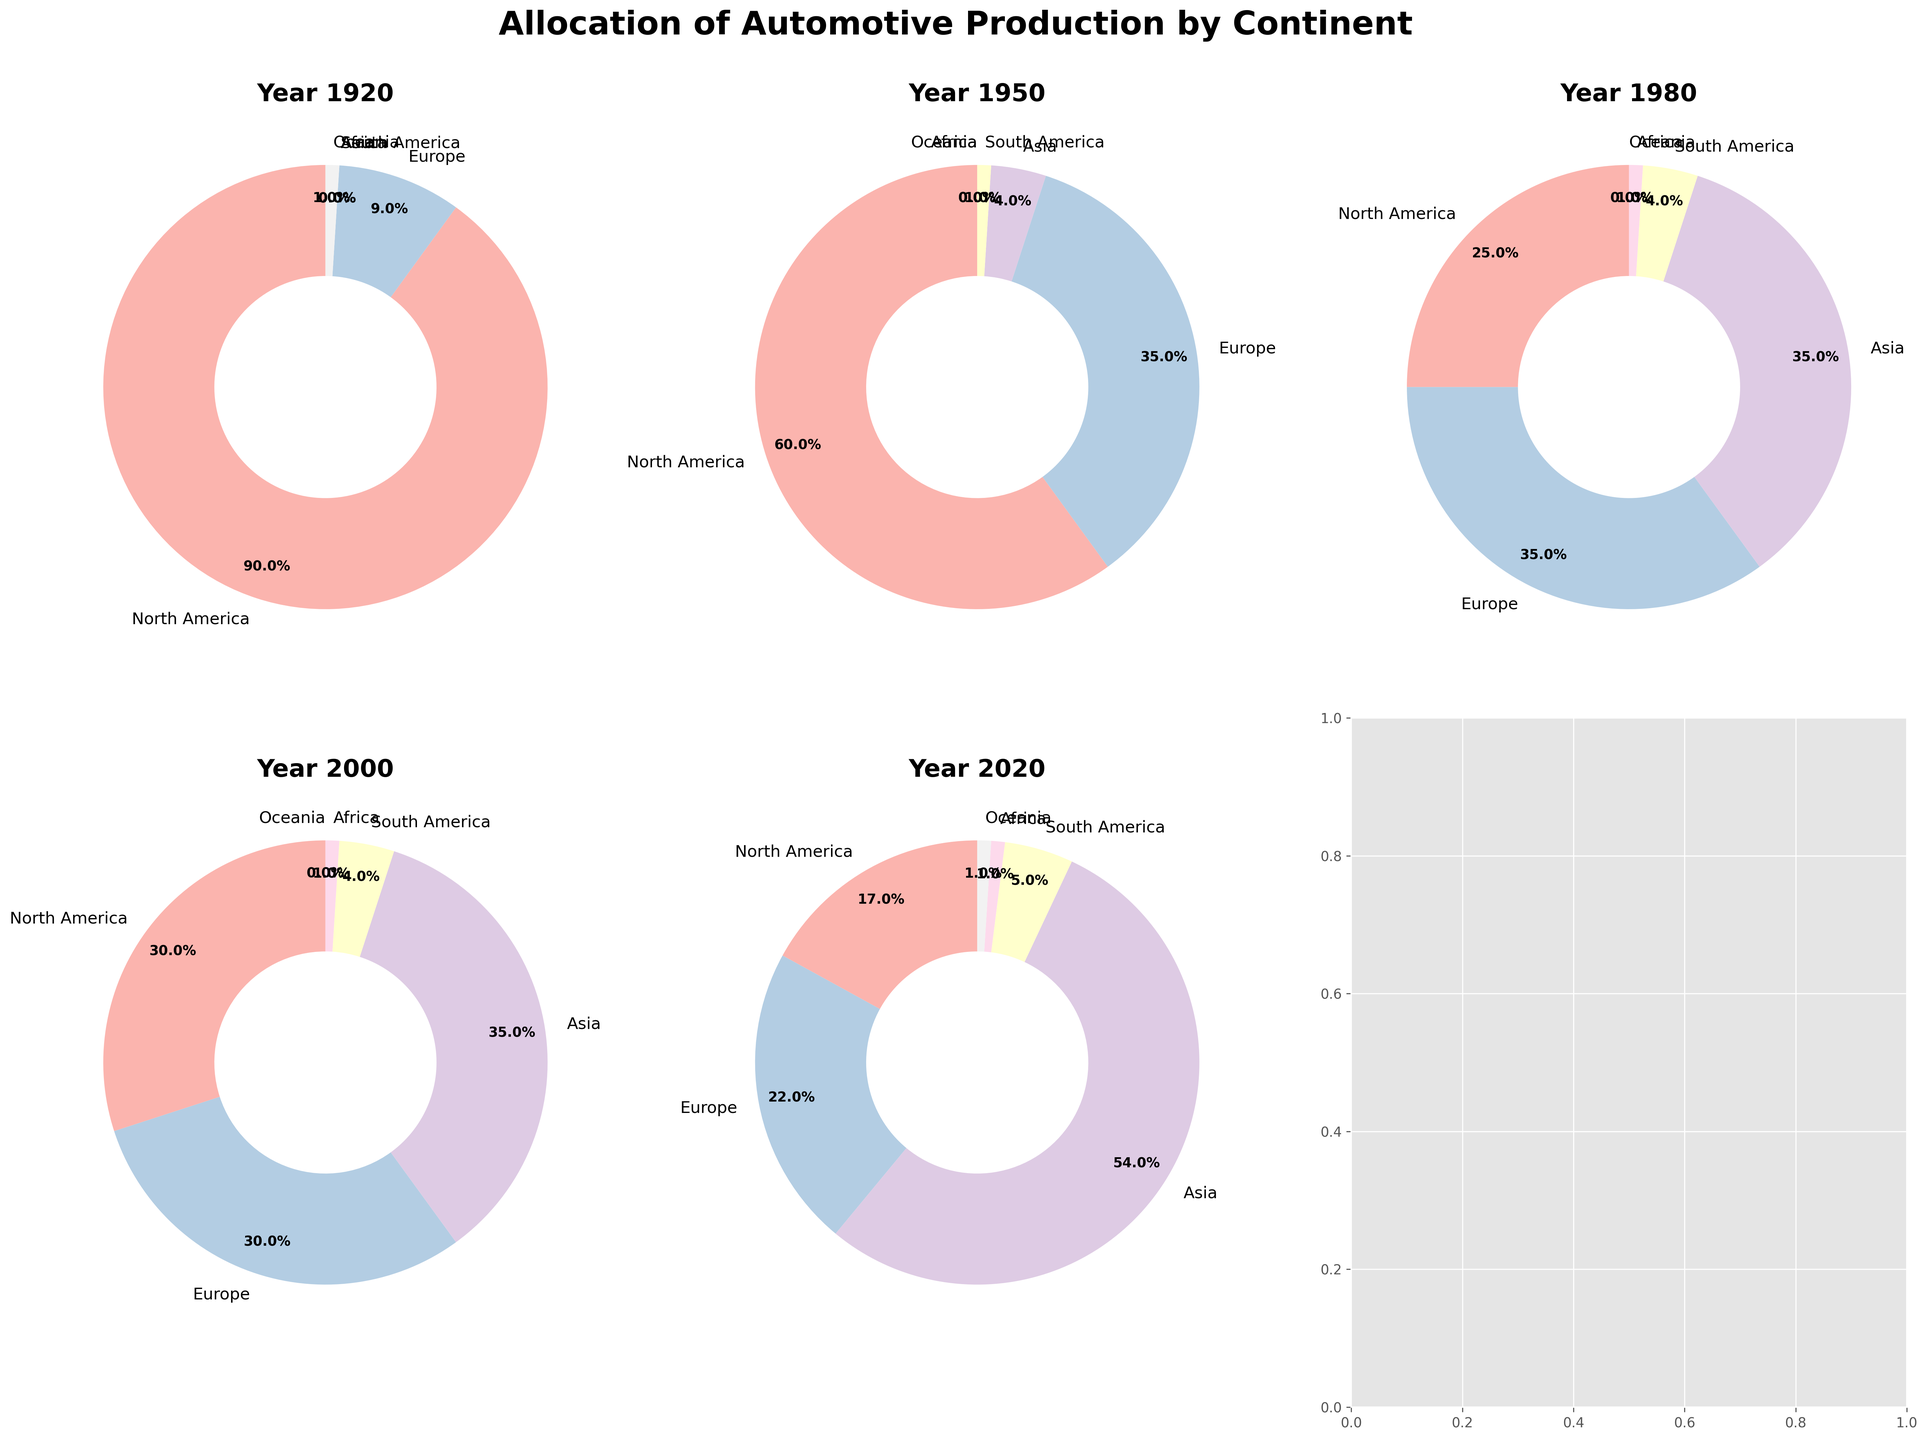what was the percentage increase in Asia's automotive production between 1980 and 2020? In 1980, Asia's allocation was 35%, and in 2020 it was 54%. The percentage increase is ((54 - 35) / 35) * 100 = 54.29%
Answer: 54.29% which continent showed the greatest decrease in automotive production share from 1920 to 2020? North America had the largest decrease, dropping from 90% in 1920 to 17% in 2020, a decrease of 73%
Answer: North America between 1950 and 2000, which continents showed stable automotive production shares with no significant change? Europe and South America both had relatively stable shares. Europe stayed consistent at 35%, and South America’s share remained stable at around 4% between these years.
Answer: Europe, South America how did the sum of automotive production percentages for Europe and Asia change from 1950 to 1980? In 1950, Europe and Asia together had (35% + 4%) = 39%. In 1980, it was (35% + 35%) = 70%. The change is 70% - 39% = 31% increase
Answer: 31% increase did North America's automotive production percentage ever increase after 1920? Between 1920 and 2020, the only increase for North America was from 25% in 1980 to 30% in 2000
Answer: Yes, from 1980 to 2000 in which year was the automotive production share evenly distributed among three continents? In 1980, North America, Europe, and Asia each had approximately 30-35% share, making the distribution more even compared to other years
Answer: 1980 how does the automotive production share for Oceania in 1920 compare to its share in 2020? In 1920, Oceania had a 1% share, and in 2020, it also had a 1% share. There was no change in the share
Answer: No change which continent had the smallest share in all the given years and what were their shares? Africa consistently had the smallest share in all years: 0% in 1920, 1950, 1% in 1980, 2000, and 2020
Answer: Africa with 0%-1% how did the collective automotive production share for Africa and South America change from 1950 to 2020? In 1950, Africa 0% + South America 1% = 1%. In 2020, Africa 1% + South America 5% = 6%. The change is 6% - 1% = 5% increase
Answer: 5% increase 